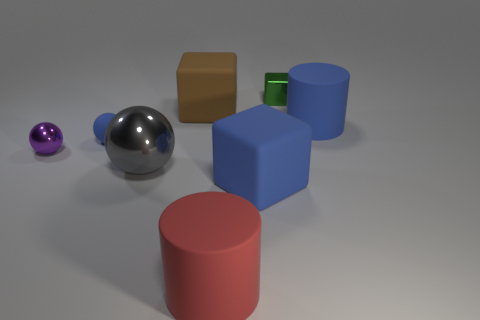Subtract all small matte spheres. How many spheres are left? 2 Add 2 large matte things. How many objects exist? 10 Subtract all cylinders. How many objects are left? 6 Subtract 1 blue cubes. How many objects are left? 7 Subtract all red cylinders. Subtract all yellow cubes. How many objects are left? 7 Add 1 small things. How many small things are left? 4 Add 5 green matte things. How many green matte things exist? 5 